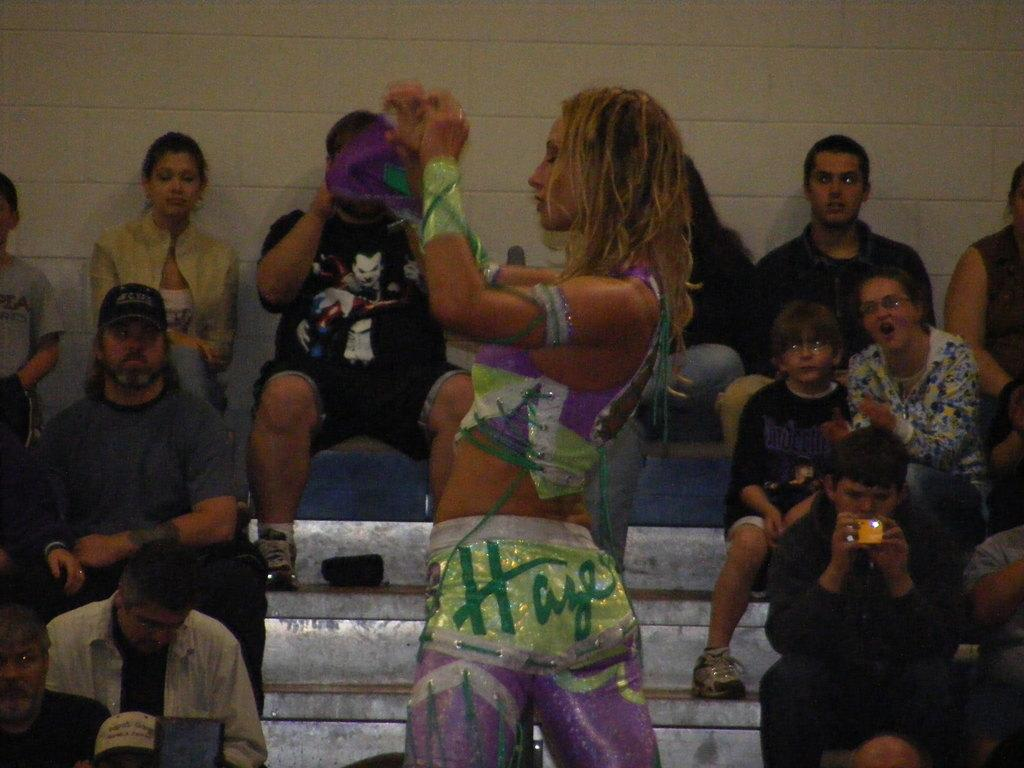What is the woman doing in the image? The woman is standing in the image. What are the other people in the image doing? There is a group of people sitting in the image. What can be seen in the background of the image? There is a wall in the background of the image. What type of pipe is visible in the image? There is no pipe present in the image. What is the rate of the woman's heartbeat in the image? It is not possible to determine the woman's heartbeat rate from the image. 